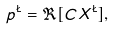<formula> <loc_0><loc_0><loc_500><loc_500>p ^ { \L } = \Re [ C X ^ { \L } ] ,</formula> 